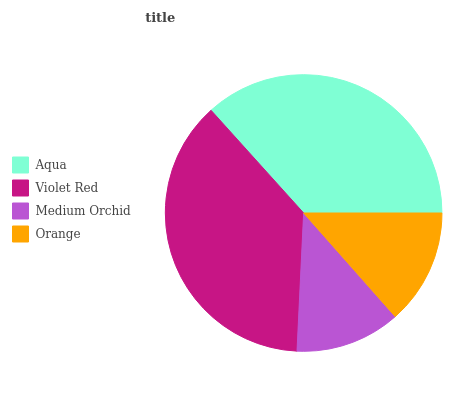Is Medium Orchid the minimum?
Answer yes or no. Yes. Is Violet Red the maximum?
Answer yes or no. Yes. Is Violet Red the minimum?
Answer yes or no. No. Is Medium Orchid the maximum?
Answer yes or no. No. Is Violet Red greater than Medium Orchid?
Answer yes or no. Yes. Is Medium Orchid less than Violet Red?
Answer yes or no. Yes. Is Medium Orchid greater than Violet Red?
Answer yes or no. No. Is Violet Red less than Medium Orchid?
Answer yes or no. No. Is Aqua the high median?
Answer yes or no. Yes. Is Orange the low median?
Answer yes or no. Yes. Is Violet Red the high median?
Answer yes or no. No. Is Aqua the low median?
Answer yes or no. No. 